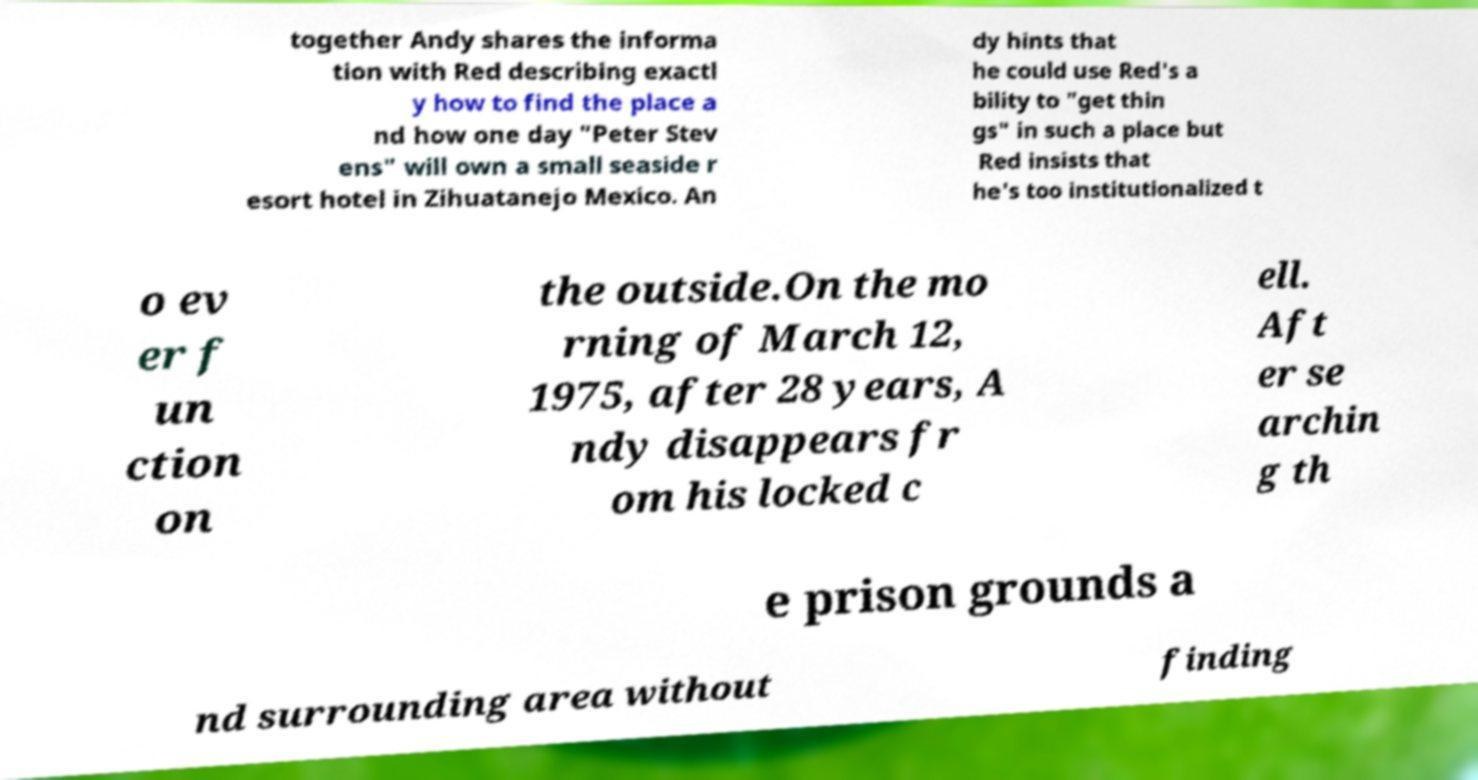Could you extract and type out the text from this image? together Andy shares the informa tion with Red describing exactl y how to find the place a nd how one day "Peter Stev ens" will own a small seaside r esort hotel in Zihuatanejo Mexico. An dy hints that he could use Red's a bility to "get thin gs" in such a place but Red insists that he's too institutionalized t o ev er f un ction on the outside.On the mo rning of March 12, 1975, after 28 years, A ndy disappears fr om his locked c ell. Aft er se archin g th e prison grounds a nd surrounding area without finding 